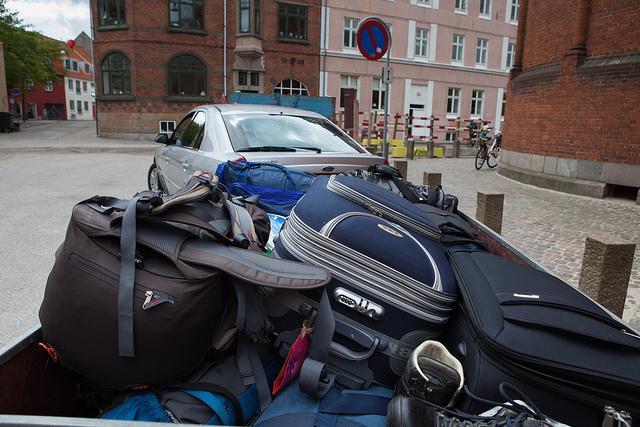What type window is the person who is photographing this luggage looking here? Please explain your reasoning. rear. I suppose. the glass is too dark. 